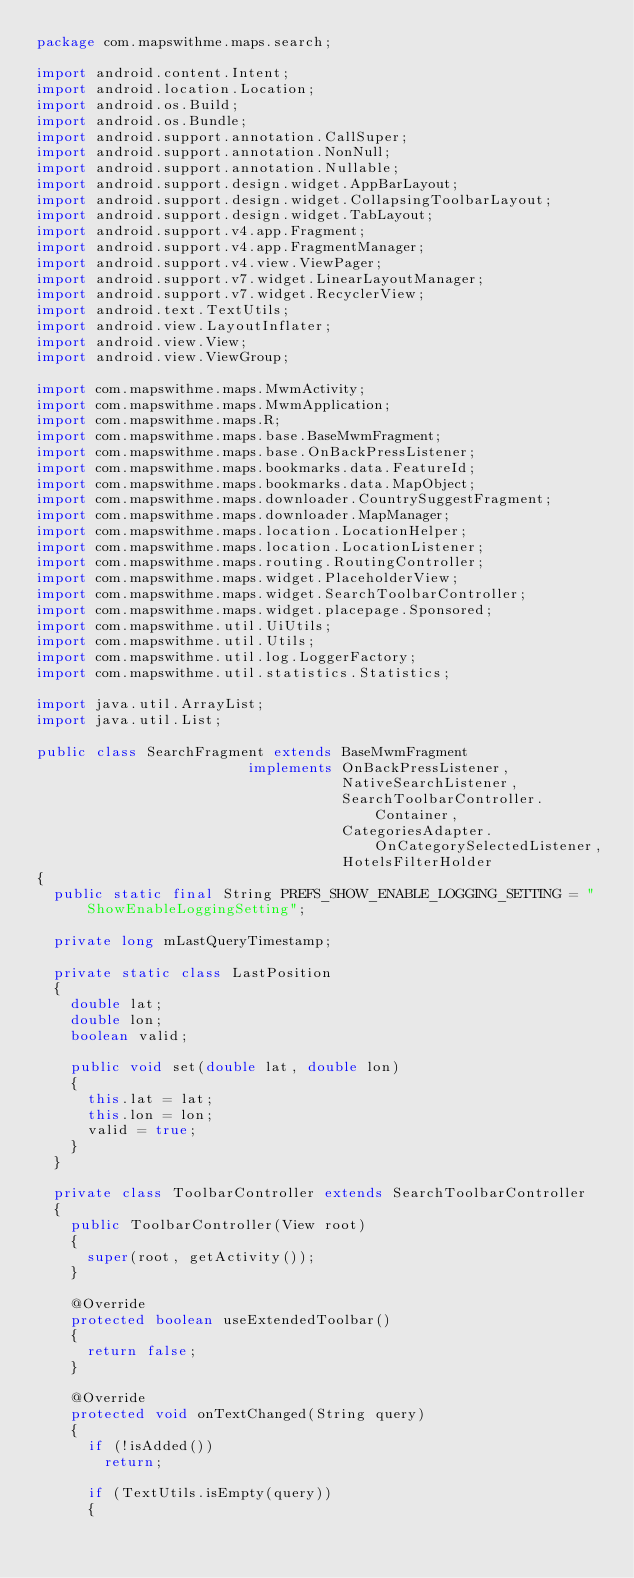<code> <loc_0><loc_0><loc_500><loc_500><_Java_>package com.mapswithme.maps.search;

import android.content.Intent;
import android.location.Location;
import android.os.Build;
import android.os.Bundle;
import android.support.annotation.CallSuper;
import android.support.annotation.NonNull;
import android.support.annotation.Nullable;
import android.support.design.widget.AppBarLayout;
import android.support.design.widget.CollapsingToolbarLayout;
import android.support.design.widget.TabLayout;
import android.support.v4.app.Fragment;
import android.support.v4.app.FragmentManager;
import android.support.v4.view.ViewPager;
import android.support.v7.widget.LinearLayoutManager;
import android.support.v7.widget.RecyclerView;
import android.text.TextUtils;
import android.view.LayoutInflater;
import android.view.View;
import android.view.ViewGroup;

import com.mapswithme.maps.MwmActivity;
import com.mapswithme.maps.MwmApplication;
import com.mapswithme.maps.R;
import com.mapswithme.maps.base.BaseMwmFragment;
import com.mapswithme.maps.base.OnBackPressListener;
import com.mapswithme.maps.bookmarks.data.FeatureId;
import com.mapswithme.maps.bookmarks.data.MapObject;
import com.mapswithme.maps.downloader.CountrySuggestFragment;
import com.mapswithme.maps.downloader.MapManager;
import com.mapswithme.maps.location.LocationHelper;
import com.mapswithme.maps.location.LocationListener;
import com.mapswithme.maps.routing.RoutingController;
import com.mapswithme.maps.widget.PlaceholderView;
import com.mapswithme.maps.widget.SearchToolbarController;
import com.mapswithme.maps.widget.placepage.Sponsored;
import com.mapswithme.util.UiUtils;
import com.mapswithme.util.Utils;
import com.mapswithme.util.log.LoggerFactory;
import com.mapswithme.util.statistics.Statistics;

import java.util.ArrayList;
import java.util.List;

public class SearchFragment extends BaseMwmFragment
                         implements OnBackPressListener,
                                    NativeSearchListener,
                                    SearchToolbarController.Container,
                                    CategoriesAdapter.OnCategorySelectedListener,
                                    HotelsFilterHolder
{
  public static final String PREFS_SHOW_ENABLE_LOGGING_SETTING = "ShowEnableLoggingSetting";

  private long mLastQueryTimestamp;

  private static class LastPosition
  {
    double lat;
    double lon;
    boolean valid;

    public void set(double lat, double lon)
    {
      this.lat = lat;
      this.lon = lon;
      valid = true;
    }
  }

  private class ToolbarController extends SearchToolbarController
  {
    public ToolbarController(View root)
    {
      super(root, getActivity());
    }

    @Override
    protected boolean useExtendedToolbar()
    {
      return false;
    }

    @Override
    protected void onTextChanged(String query)
    {
      if (!isAdded())
        return;

      if (TextUtils.isEmpty(query))
      {</code> 